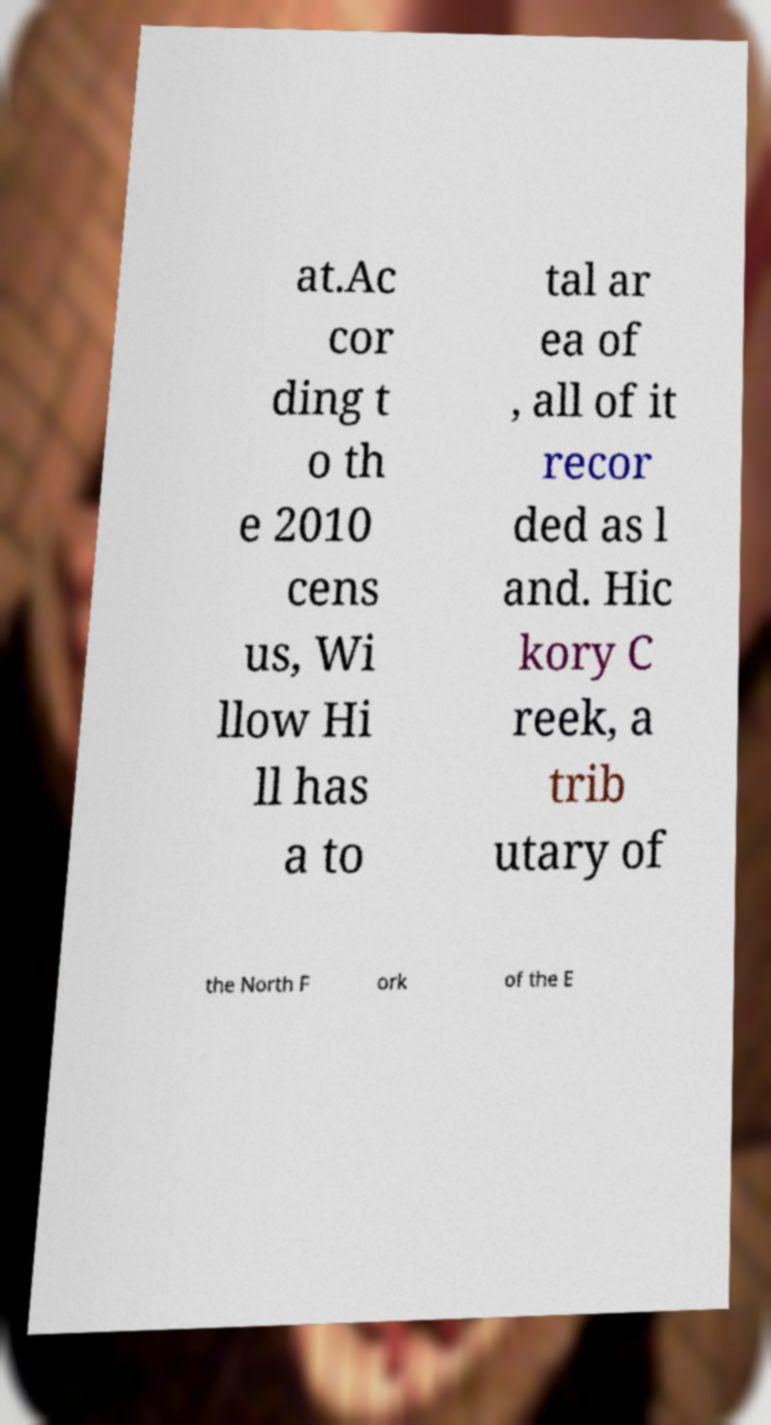Please read and relay the text visible in this image. What does it say? at.Ac cor ding t o th e 2010 cens us, Wi llow Hi ll has a to tal ar ea of , all of it recor ded as l and. Hic kory C reek, a trib utary of the North F ork of the E 